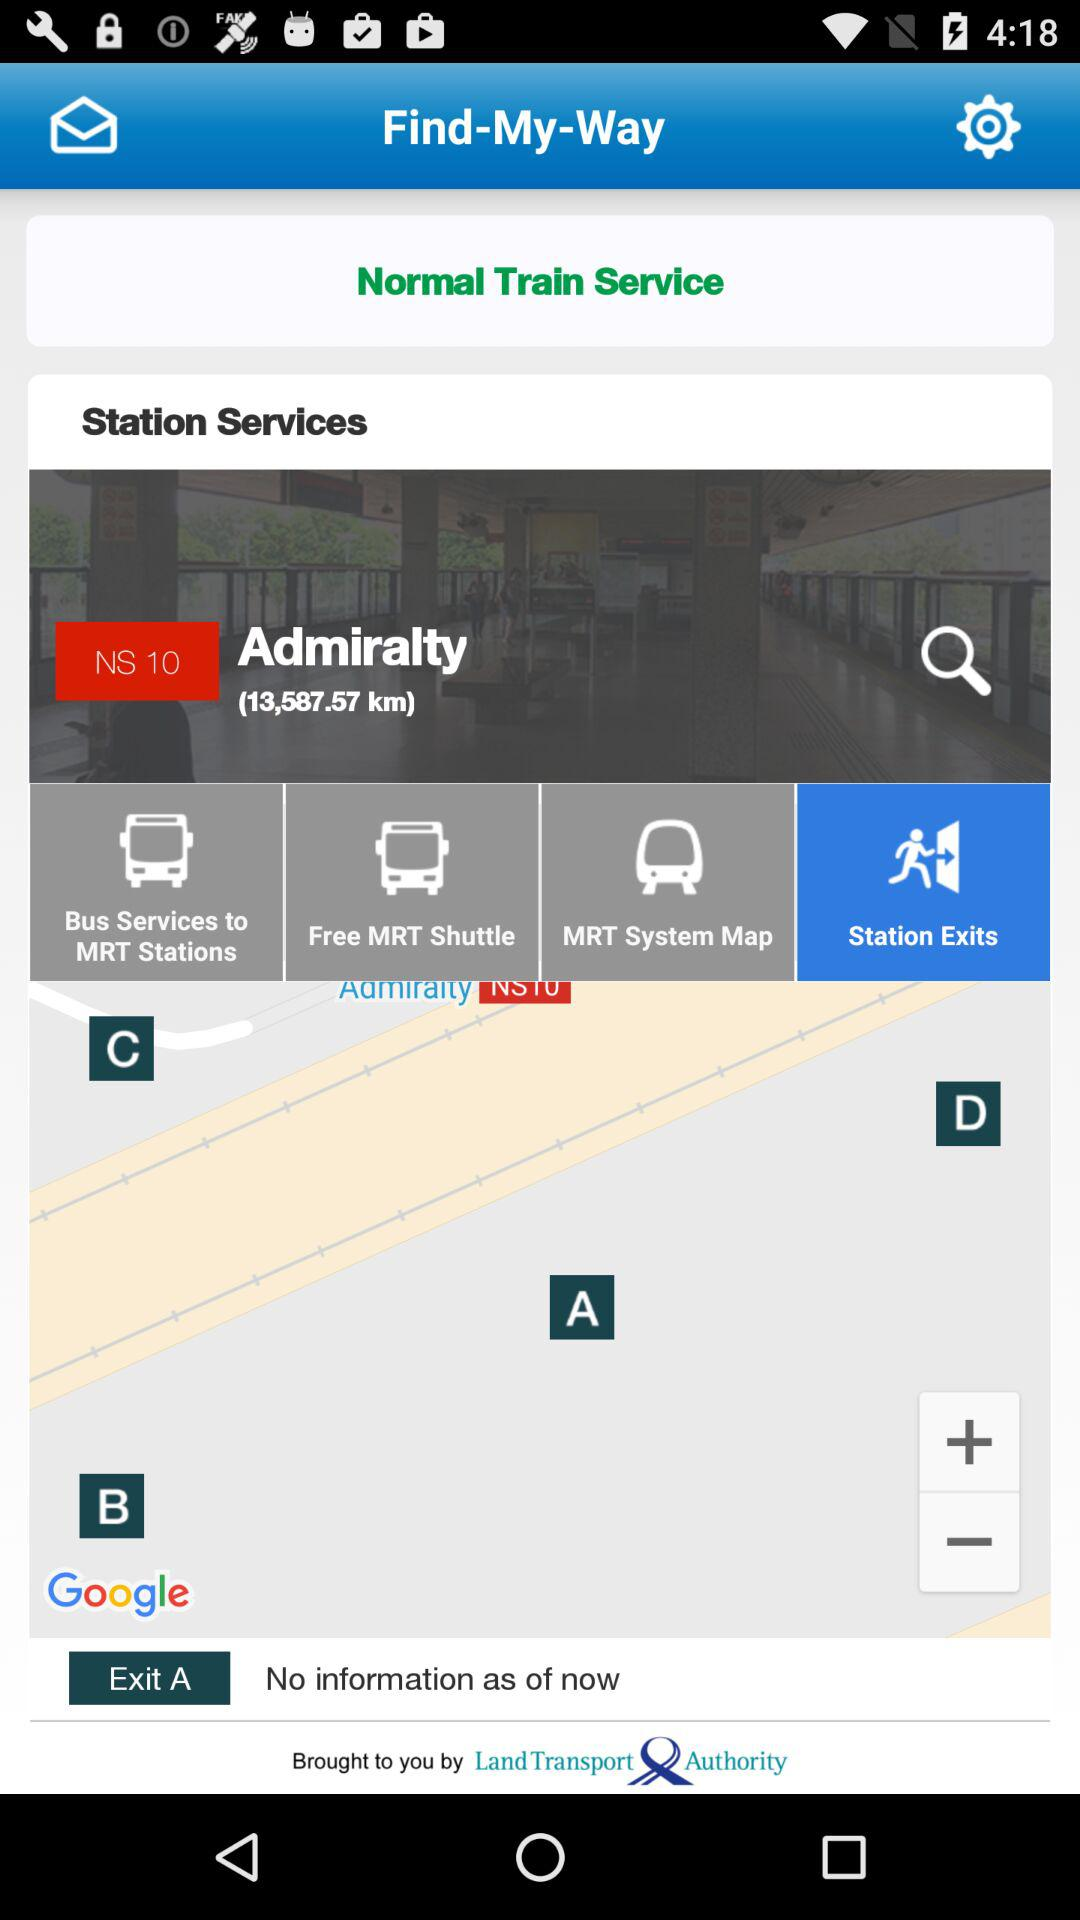Which tab is selected right now? The selected tab is "Station Exits". 